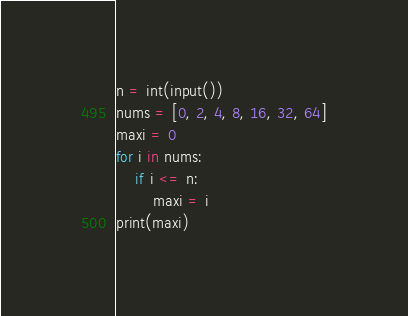<code> <loc_0><loc_0><loc_500><loc_500><_Python_>n = int(input())
nums = [0, 2, 4, 8, 16, 32, 64]
maxi = 0
for i in nums:
    if i <= n:
        maxi = i
print(maxi)</code> 